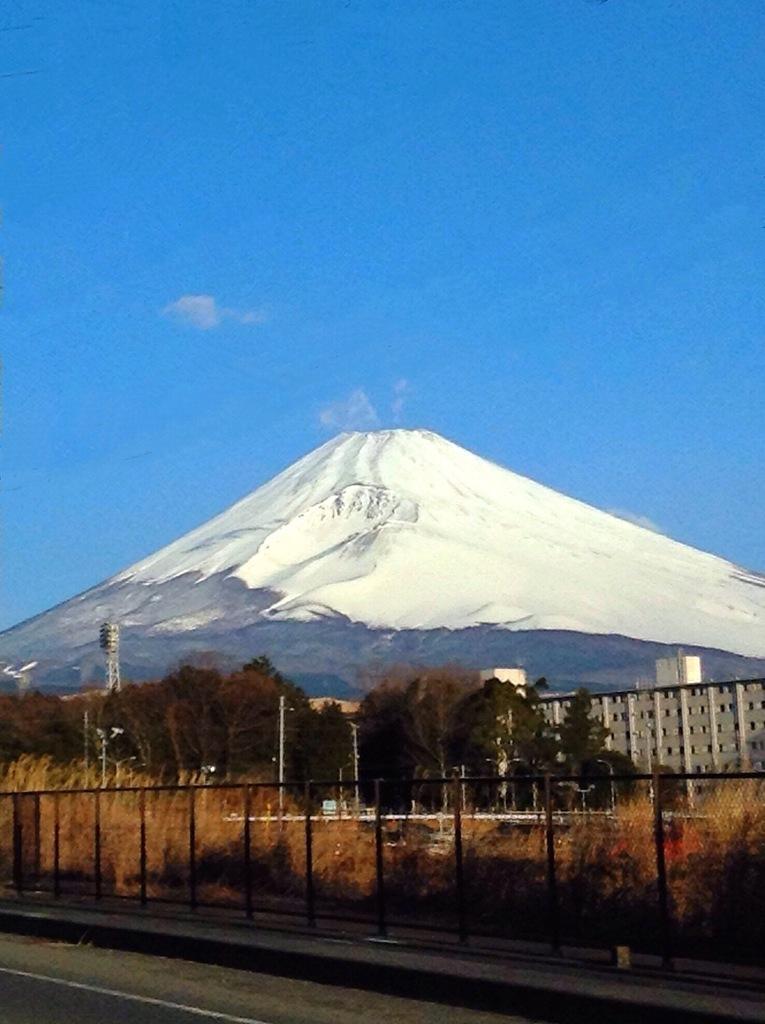Describe this image in one or two sentences. This picture is clicked outside. In the foreground we can see the ground, grass, plants, trees, metal rods, mesh, buildings and some other objects. In the background we can see the sky and the hill. 